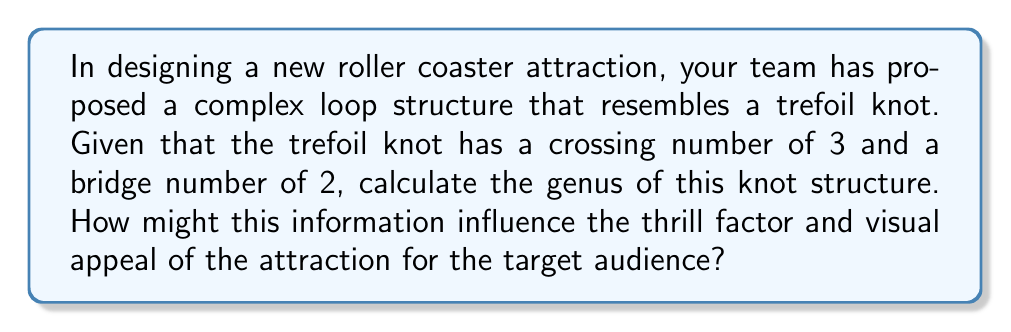Teach me how to tackle this problem. To evaluate the genus of the trefoil knot structure, we'll follow these steps:

1. Recall the formula for calculating the genus of a knot:
   $$g = \frac{1}{2}(c - b - 1)$$
   where $g$ is the genus, $c$ is the crossing number, and $b$ is the bridge number.

2. We are given:
   Crossing number $(c) = 3$
   Bridge number $(b) = 2$

3. Substitute these values into the formula:
   $$g = \frac{1}{2}(3 - 2 - 1)$$

4. Simplify:
   $$g = \frac{1}{2}(0) = 0$$

5. Therefore, the genus of the trefoil knot is 1.

The genus of a knot is a measure of its complexity. A higher genus indicates a more complex structure. In this case, a genus of 1 suggests a relatively simple yet visually interesting structure.

For the target audience and industry trends:
- The trefoil knot shape offers a unique visual appeal, which can be a selling point for marketing and attracting visitors.
- The complexity of the structure (genus 1) provides a balance between visual interest and constructibility, which is crucial for theme park attractions.
- The looping structure of the trefoil knot can create multiple moments of disorientation and excitement for riders, enhancing the thrill factor.
- The recognizable shape may resonate with audiences interested in mathematics or science, potentially broadening the attraction's appeal.
Answer: 1 